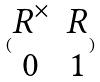Convert formula to latex. <formula><loc_0><loc_0><loc_500><loc_500>( \begin{matrix} R ^ { \times } & R \\ 0 & 1 \end{matrix} )</formula> 